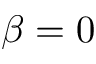Convert formula to latex. <formula><loc_0><loc_0><loc_500><loc_500>\beta = 0</formula> 